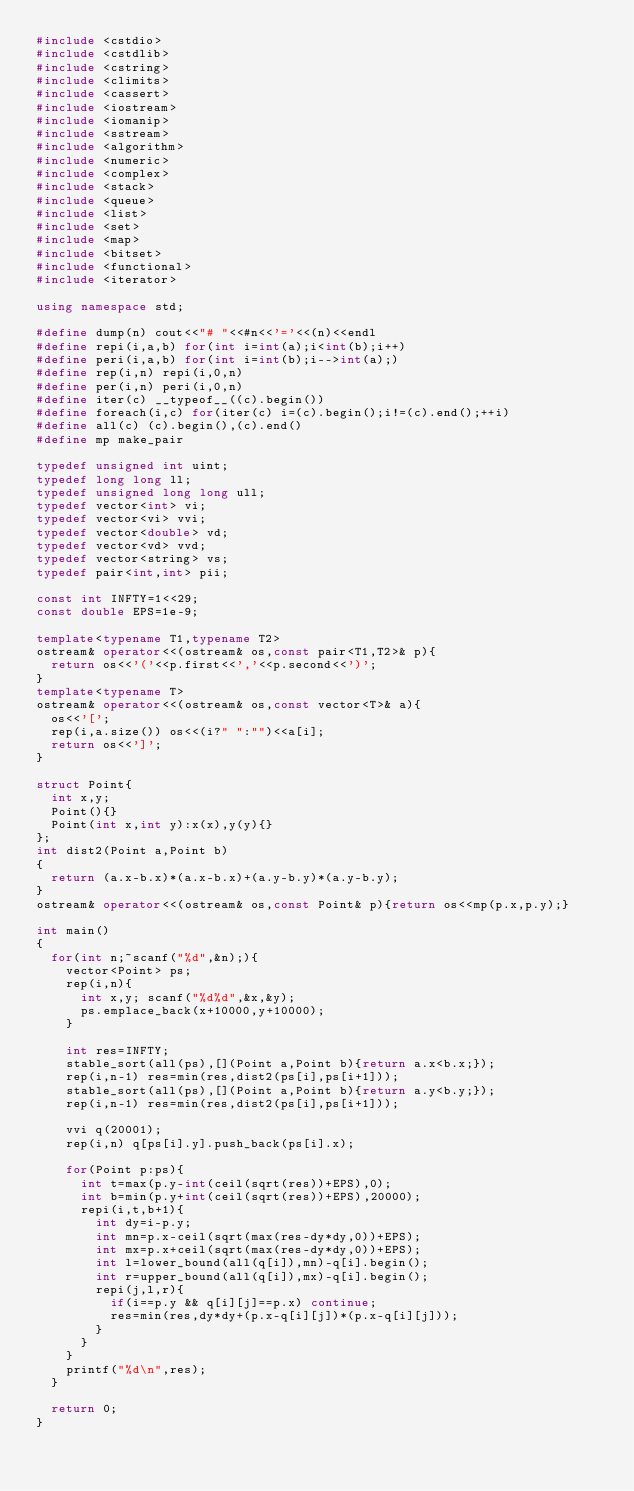Convert code to text. <code><loc_0><loc_0><loc_500><loc_500><_C++_>#include <cstdio>
#include <cstdlib>
#include <cstring>
#include <climits>
#include <cassert>
#include <iostream>
#include <iomanip>
#include <sstream>
#include <algorithm>
#include <numeric>
#include <complex>
#include <stack>
#include <queue>
#include <list>
#include <set>
#include <map>
#include <bitset>
#include <functional>
#include <iterator>

using namespace std;

#define dump(n) cout<<"# "<<#n<<'='<<(n)<<endl
#define repi(i,a,b) for(int i=int(a);i<int(b);i++)
#define peri(i,a,b) for(int i=int(b);i-->int(a);)
#define rep(i,n) repi(i,0,n)
#define per(i,n) peri(i,0,n)
#define iter(c) __typeof__((c).begin())
#define foreach(i,c) for(iter(c) i=(c).begin();i!=(c).end();++i)
#define all(c) (c).begin(),(c).end()
#define mp make_pair

typedef unsigned int uint;
typedef long long ll;
typedef unsigned long long ull;
typedef vector<int> vi;
typedef vector<vi> vvi;
typedef vector<double> vd;
typedef vector<vd> vvd;
typedef vector<string> vs;
typedef pair<int,int> pii;

const int INFTY=1<<29;
const double EPS=1e-9;

template<typename T1,typename T2>
ostream& operator<<(ostream& os,const pair<T1,T2>& p){
	return os<<'('<<p.first<<','<<p.second<<')';
}
template<typename T>
ostream& operator<<(ostream& os,const vector<T>& a){
	os<<'[';
	rep(i,a.size()) os<<(i?" ":"")<<a[i];
	return os<<']';
}

struct Point{
	int x,y;
	Point(){}
	Point(int x,int y):x(x),y(y){}
};
int dist2(Point a,Point b)
{
	return (a.x-b.x)*(a.x-b.x)+(a.y-b.y)*(a.y-b.y);
}
ostream& operator<<(ostream& os,const Point& p){return os<<mp(p.x,p.y);}

int main()
{
	for(int n;~scanf("%d",&n);){
		vector<Point> ps;
		rep(i,n){
			int x,y; scanf("%d%d",&x,&y);
			ps.emplace_back(x+10000,y+10000);
		}
		
		int res=INFTY;
		stable_sort(all(ps),[](Point a,Point b){return a.x<b.x;});
		rep(i,n-1) res=min(res,dist2(ps[i],ps[i+1]));
		stable_sort(all(ps),[](Point a,Point b){return a.y<b.y;});
		rep(i,n-1) res=min(res,dist2(ps[i],ps[i+1]));
		
		vvi q(20001);
		rep(i,n) q[ps[i].y].push_back(ps[i].x);
		
		for(Point p:ps){
			int t=max(p.y-int(ceil(sqrt(res))+EPS),0);
			int b=min(p.y+int(ceil(sqrt(res))+EPS),20000);
			repi(i,t,b+1){
				int dy=i-p.y;
				int mn=p.x-ceil(sqrt(max(res-dy*dy,0))+EPS);
				int mx=p.x+ceil(sqrt(max(res-dy*dy,0))+EPS);
				int l=lower_bound(all(q[i]),mn)-q[i].begin();
				int r=upper_bound(all(q[i]),mx)-q[i].begin();
				repi(j,l,r){
					if(i==p.y && q[i][j]==p.x) continue;
					res=min(res,dy*dy+(p.x-q[i][j])*(p.x-q[i][j]));
				}
			}
		}
		printf("%d\n",res);
	}
	
	return 0;
}</code> 